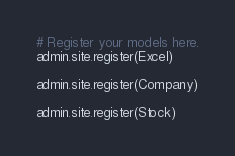Convert code to text. <code><loc_0><loc_0><loc_500><loc_500><_Python_># Register your models here.
admin.site.register(Excel)

admin.site.register(Company)

admin.site.register(Stock)

</code> 